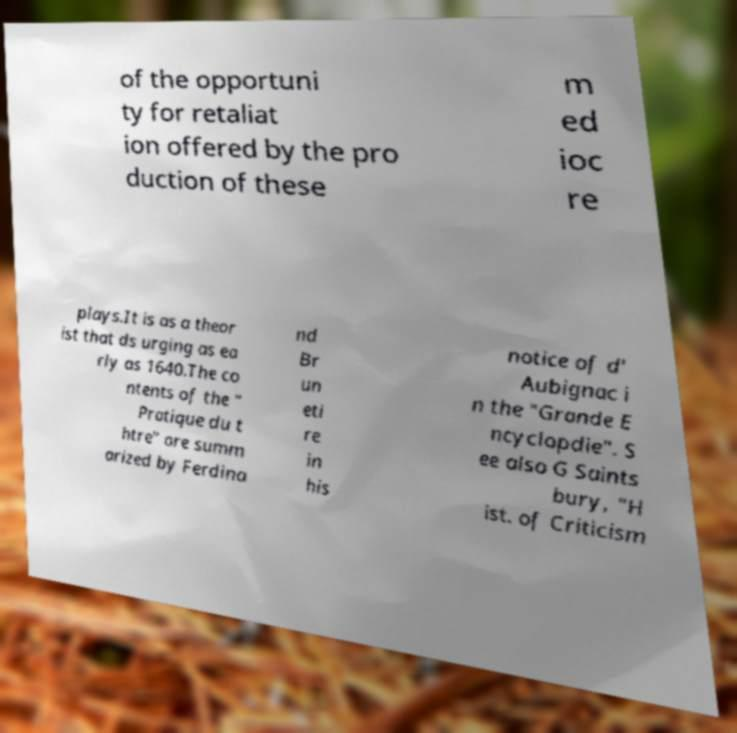Can you accurately transcribe the text from the provided image for me? of the opportuni ty for retaliat ion offered by the pro duction of these m ed ioc re plays.It is as a theor ist that ds urging as ea rly as 1640.The co ntents of the " Pratique du t htre" are summ arized by Ferdina nd Br un eti re in his notice of d' Aubignac i n the "Grande E ncyclopdie". S ee also G Saints bury, "H ist. of Criticism 